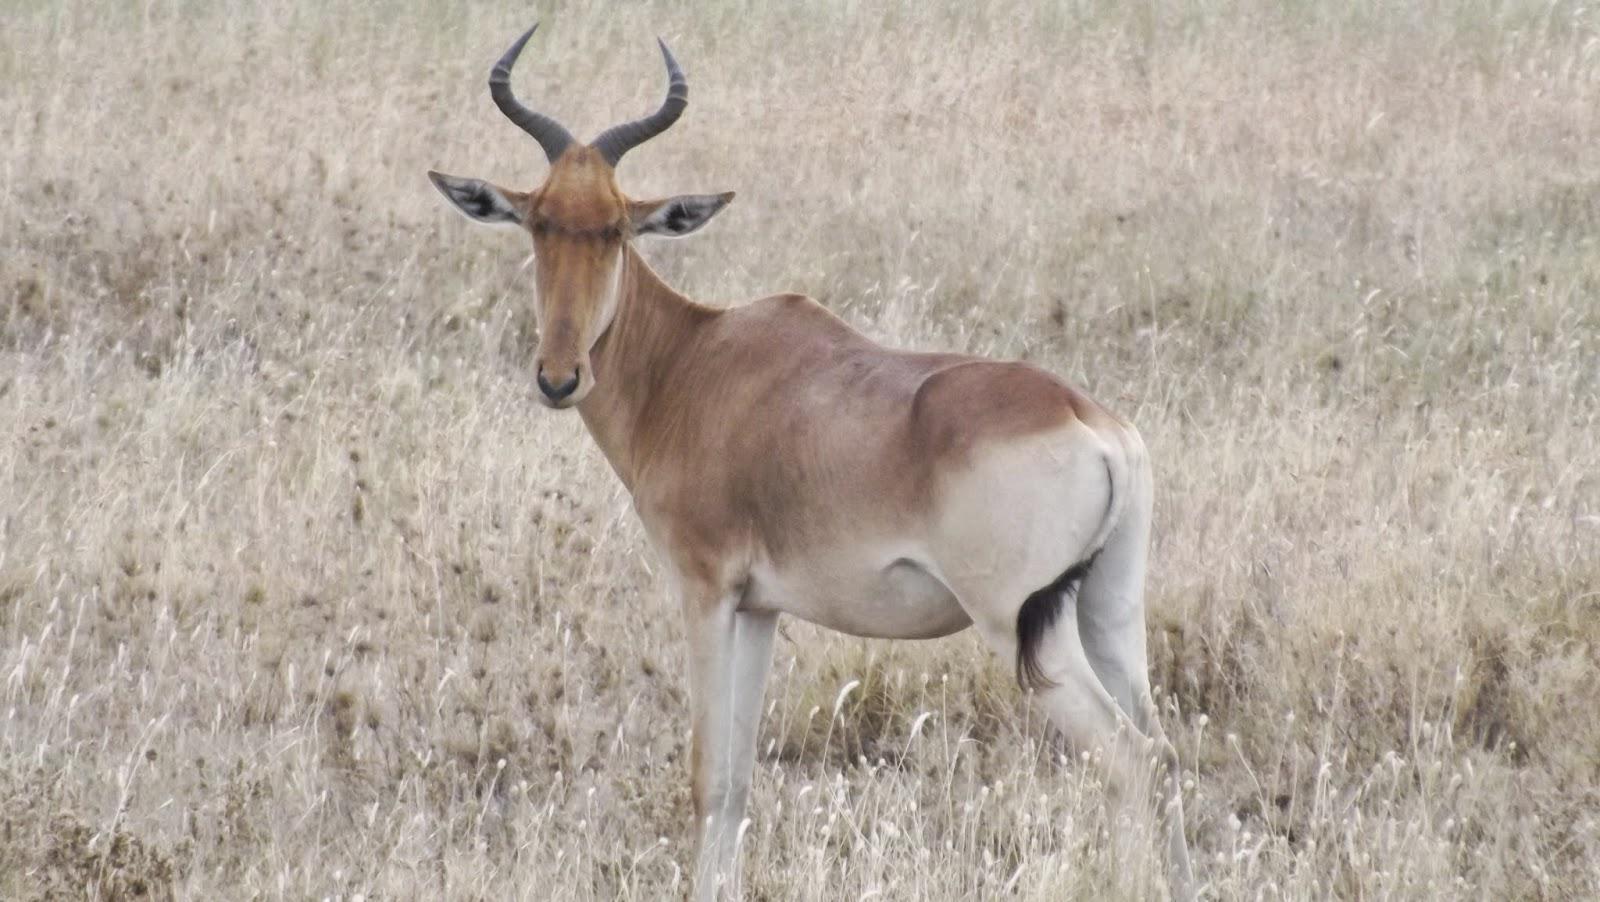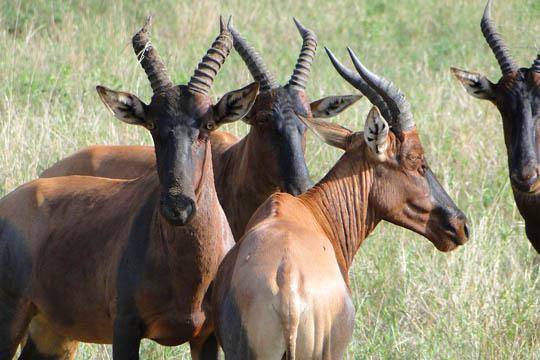The first image is the image on the left, the second image is the image on the right. Assess this claim about the two images: "The left and right image contains a total of three elk.". Correct or not? Answer yes or no. No. The first image is the image on the left, the second image is the image on the right. Considering the images on both sides, is "One image contains exactly twice as many hooved animals in the foreground as the other image." valid? Answer yes or no. No. 